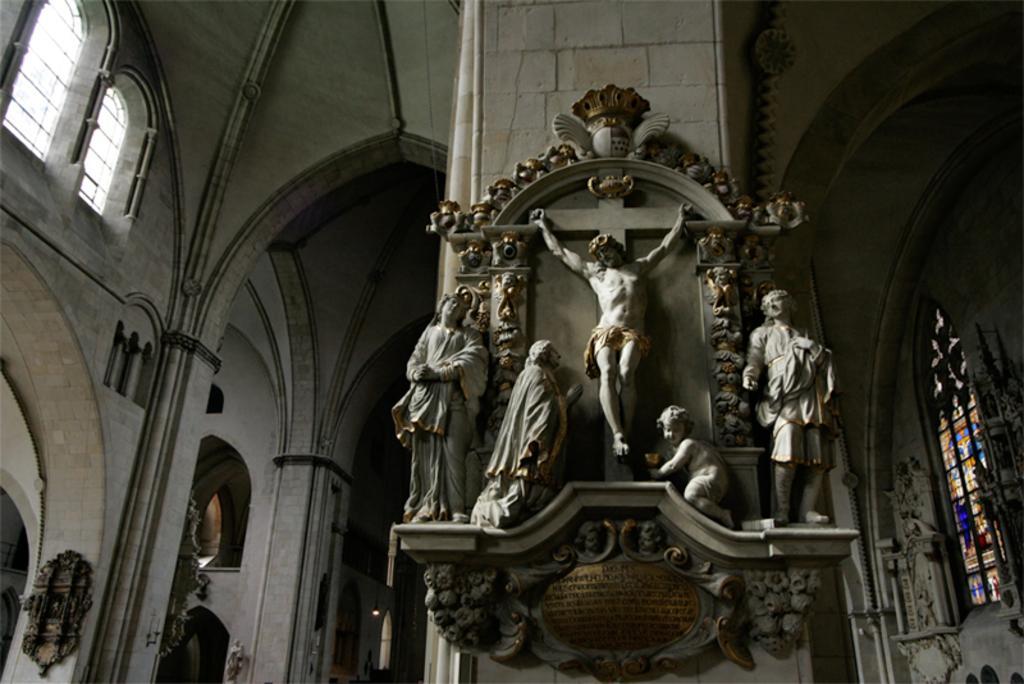How would you summarize this image in a sentence or two? In this image we can see status on a platform on the wall and at the bottom there are texts written on the platform. In the background we can see windows, objects on the wall and a light. 